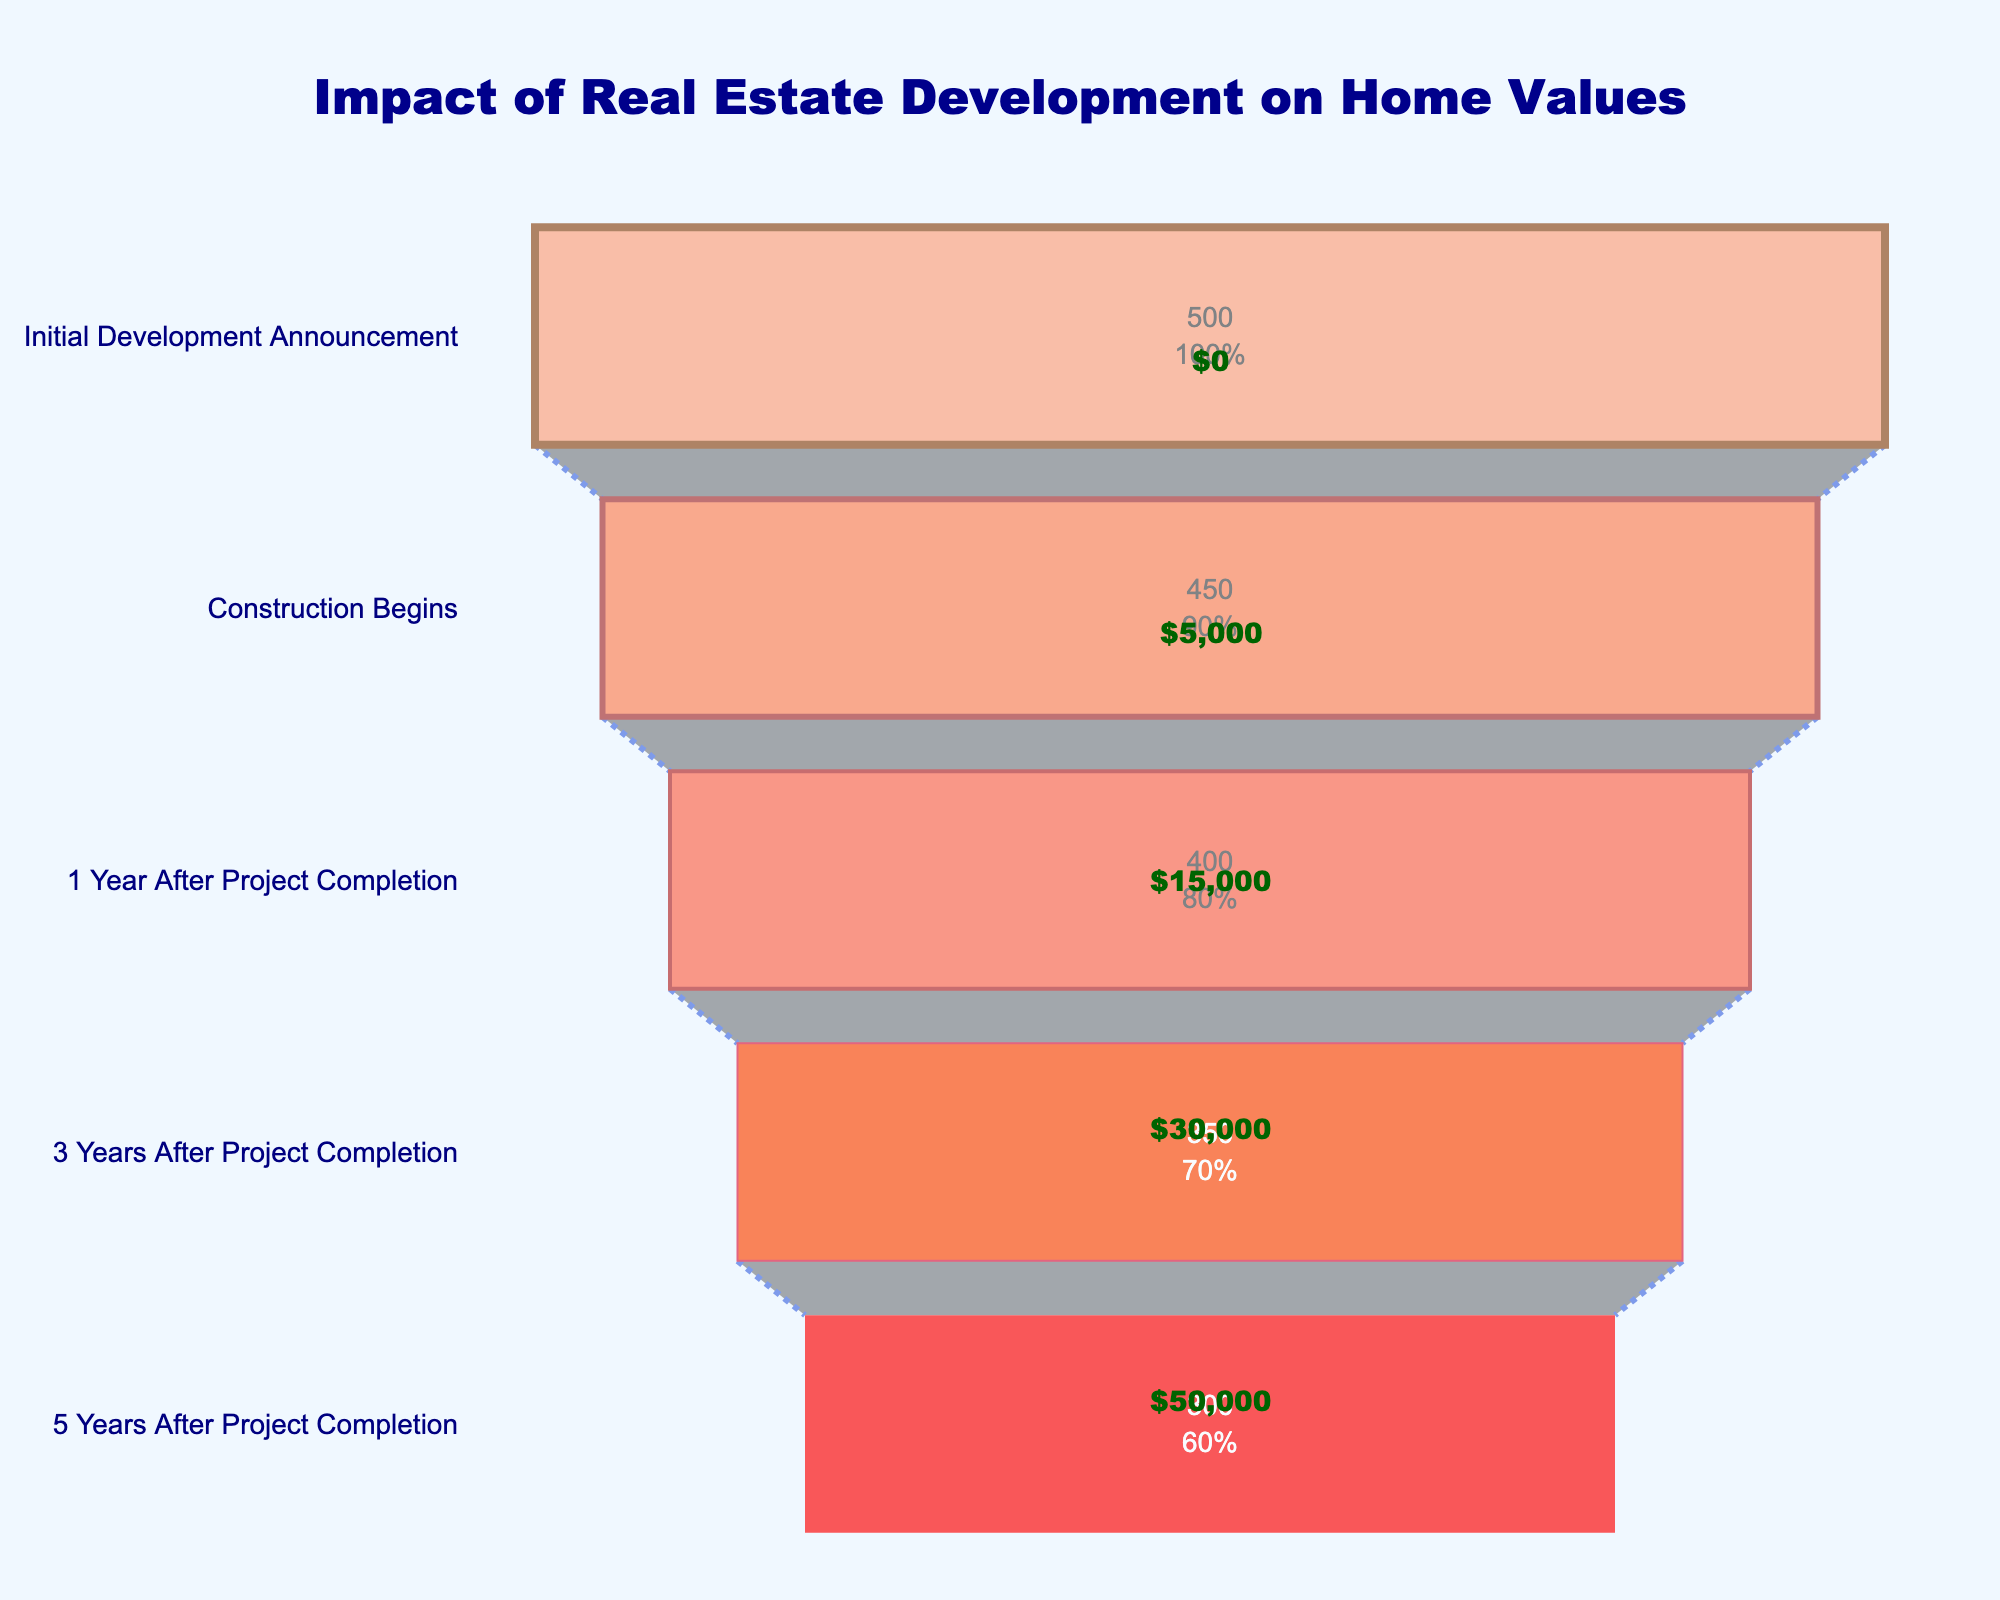Which stage has the highest number of affected homes? Look at the funnel chart and identify the stage with the longest bar, which corresponds to the highest number of affected homes. The longest bar is at the "Initial Development Announcement" stage, suggesting it has the highest number of affected homes.
Answer: Initial Development Announcement What is the average value change at the stage with the fewest affected homes? Identify the stage with the shortest bar, which is "5 Years After Project Completion." Then, check the annotation for this stage, which shows an average value change of $50,000.
Answer: $50,000 How many stages show a decrease in the number of affected homes? Observe each bar in the funnel chart and count the number of stages where the number of affected homes decreases compared to the previous stage. There are decreases in all stages except the initial one, so there are 4 stages showing a decrease.
Answer: 4 By how much does the average value change 3 years after project completion compared to the initial development announcement? Note that the average value change at "Initial Development Announcement" is $0 and at "3 Years After Project Completion" is $30,000. The difference between these two values is $30,000.
Answer: $30,000 What is the percentage decrease in the number of affected homes from the initial development announcement to construction begin? There are initially 500 homes affected and then 450 during construction. To find the percentage decrease: (500 - 450) / 500 * 100% = 10%.
Answer: 10% Which stage has the most significant average value change, and what is its value? Look at the annotations and identify the stage with the highest average value change, which is "5 Years After Project Completion" with $50,000.
Answer: 5 Years After Project Completion, $50,000 What is the cumulative average value change from the initial announcement to 3 years after project completion? Sum up the average value changes at each relevant stage: $0 (Initial) + $5,000 (Construction Begins) + $15,000 (1 Year After) + $30,000 (3 Years After) = $50,000.
Answer: $50,000 How many homes are affected 1 year after the project completion? Look at the funnel chart to see the number of affected homes at the stage "1 Year After Project Completion", which shows 400 homes.
Answer: 400 What is the total decrease in the number of homes affected from the initial announcement to 5 years after project completion? Subtract the final number of affected homes from the initial number: 500 (Initial) - 300 (5 Years After) = 200 homes.
Answer: 200 homes 